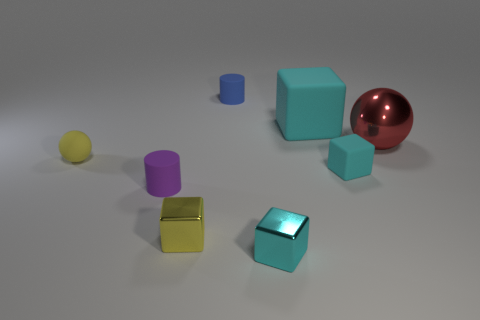Are there any patterns or designs on any of the objects? No, all objects in the image have a solid color and lack any visible patterns, designs, or textures. This simplicity in appearance directs focus towards their shapes and the composition of the scene. 